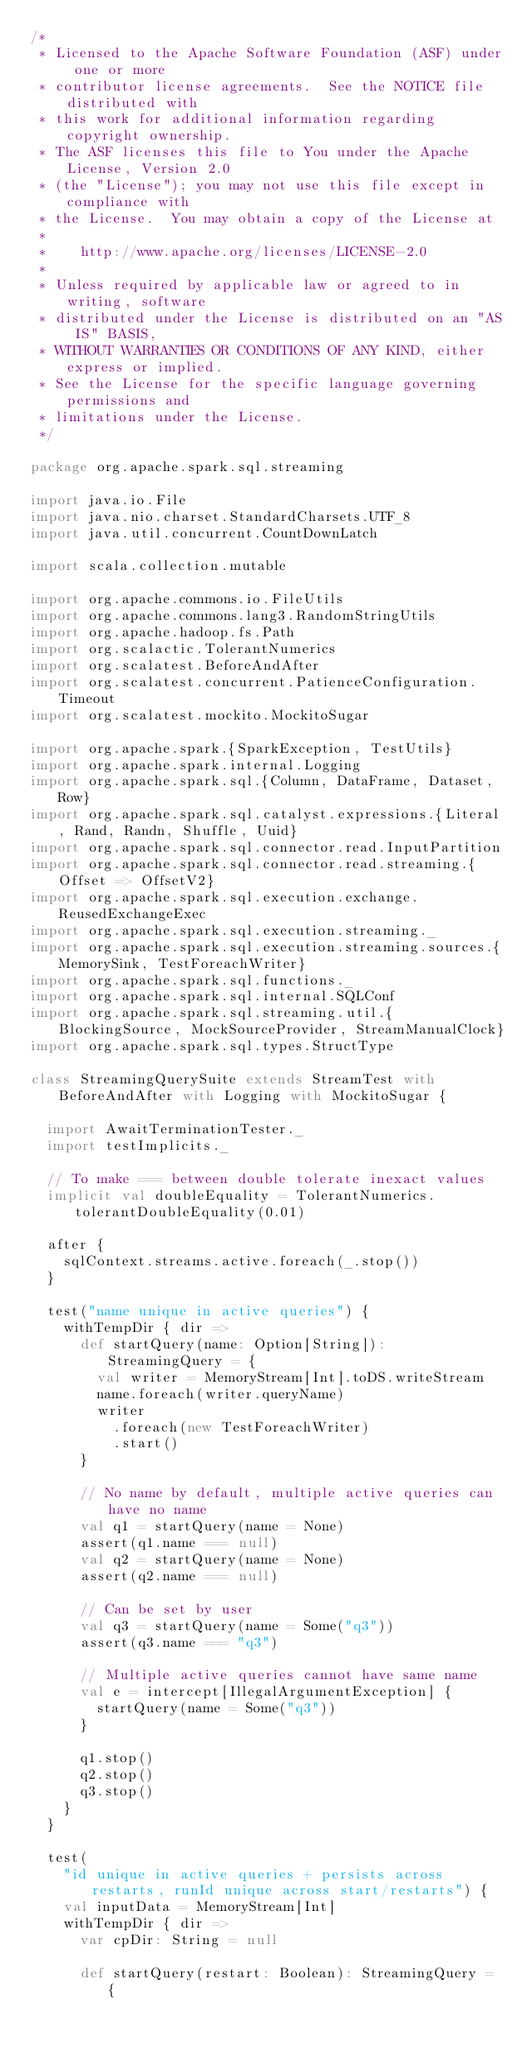<code> <loc_0><loc_0><loc_500><loc_500><_Scala_>/*
 * Licensed to the Apache Software Foundation (ASF) under one or more
 * contributor license agreements.  See the NOTICE file distributed with
 * this work for additional information regarding copyright ownership.
 * The ASF licenses this file to You under the Apache License, Version 2.0
 * (the "License"); you may not use this file except in compliance with
 * the License.  You may obtain a copy of the License at
 *
 *    http://www.apache.org/licenses/LICENSE-2.0
 *
 * Unless required by applicable law or agreed to in writing, software
 * distributed under the License is distributed on an "AS IS" BASIS,
 * WITHOUT WARRANTIES OR CONDITIONS OF ANY KIND, either express or implied.
 * See the License for the specific language governing permissions and
 * limitations under the License.
 */

package org.apache.spark.sql.streaming

import java.io.File
import java.nio.charset.StandardCharsets.UTF_8
import java.util.concurrent.CountDownLatch

import scala.collection.mutable

import org.apache.commons.io.FileUtils
import org.apache.commons.lang3.RandomStringUtils
import org.apache.hadoop.fs.Path
import org.scalactic.TolerantNumerics
import org.scalatest.BeforeAndAfter
import org.scalatest.concurrent.PatienceConfiguration.Timeout
import org.scalatest.mockito.MockitoSugar

import org.apache.spark.{SparkException, TestUtils}
import org.apache.spark.internal.Logging
import org.apache.spark.sql.{Column, DataFrame, Dataset, Row}
import org.apache.spark.sql.catalyst.expressions.{Literal, Rand, Randn, Shuffle, Uuid}
import org.apache.spark.sql.connector.read.InputPartition
import org.apache.spark.sql.connector.read.streaming.{Offset => OffsetV2}
import org.apache.spark.sql.execution.exchange.ReusedExchangeExec
import org.apache.spark.sql.execution.streaming._
import org.apache.spark.sql.execution.streaming.sources.{MemorySink, TestForeachWriter}
import org.apache.spark.sql.functions._
import org.apache.spark.sql.internal.SQLConf
import org.apache.spark.sql.streaming.util.{BlockingSource, MockSourceProvider, StreamManualClock}
import org.apache.spark.sql.types.StructType

class StreamingQuerySuite extends StreamTest with BeforeAndAfter with Logging with MockitoSugar {

  import AwaitTerminationTester._
  import testImplicits._

  // To make === between double tolerate inexact values
  implicit val doubleEquality = TolerantNumerics.tolerantDoubleEquality(0.01)

  after {
    sqlContext.streams.active.foreach(_.stop())
  }

  test("name unique in active queries") {
    withTempDir { dir =>
      def startQuery(name: Option[String]): StreamingQuery = {
        val writer = MemoryStream[Int].toDS.writeStream
        name.foreach(writer.queryName)
        writer
          .foreach(new TestForeachWriter)
          .start()
      }

      // No name by default, multiple active queries can have no name
      val q1 = startQuery(name = None)
      assert(q1.name === null)
      val q2 = startQuery(name = None)
      assert(q2.name === null)

      // Can be set by user
      val q3 = startQuery(name = Some("q3"))
      assert(q3.name === "q3")

      // Multiple active queries cannot have same name
      val e = intercept[IllegalArgumentException] {
        startQuery(name = Some("q3"))
      }

      q1.stop()
      q2.stop()
      q3.stop()
    }
  }

  test(
    "id unique in active queries + persists across restarts, runId unique across start/restarts") {
    val inputData = MemoryStream[Int]
    withTempDir { dir =>
      var cpDir: String = null

      def startQuery(restart: Boolean): StreamingQuery = {</code> 